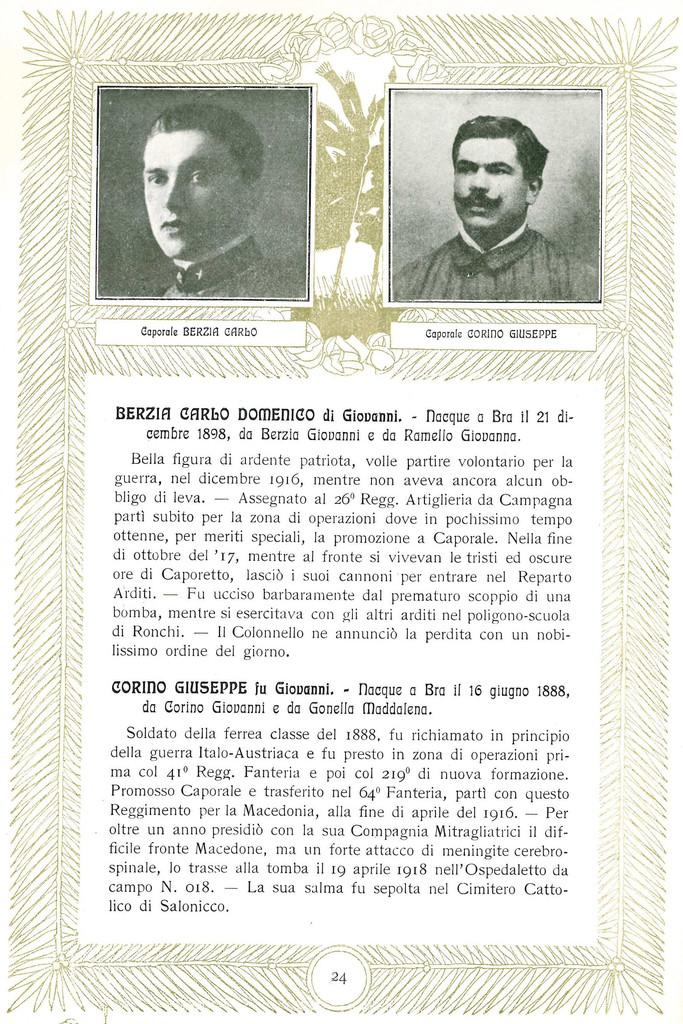What is present on the poster in the image? There is a poster in the image. What can be seen on the poster besides the design elements? The poster contains pictures and text. Can you describe any design elements on the poster? The poster has some design elements, but their specific details are not mentioned in the provided facts. What type of pickle is being used as a treatment in the image? There is no pickle or treatment present in the image. What color is the sky in the image? The provided facts do not mention the sky or its color in the image. 